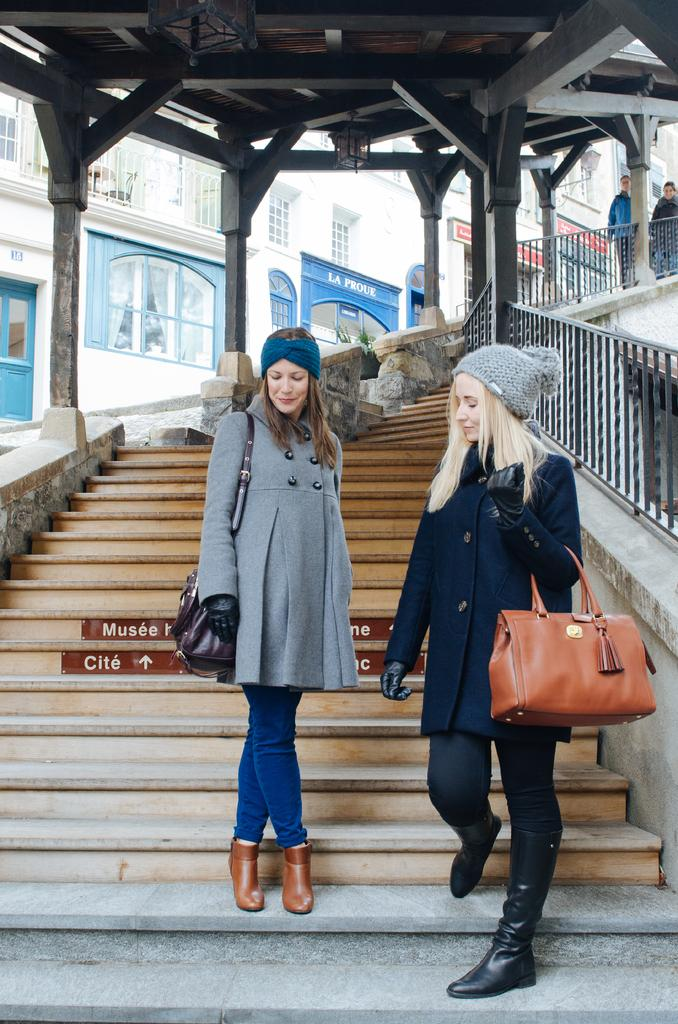Who is present in the image? There are women in the image. What are the women doing in the image? The women are standing on stairs. What is one of the women holding? One of the women is holding a bag. What are the women wearing on their heads? The women are wearing caps. How far away is the ocean from the women in the image? There is no ocean visible in the image, so it is not possible to determine the distance between the women and the ocean. 